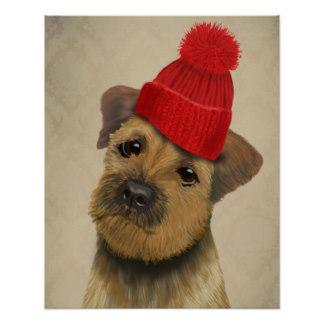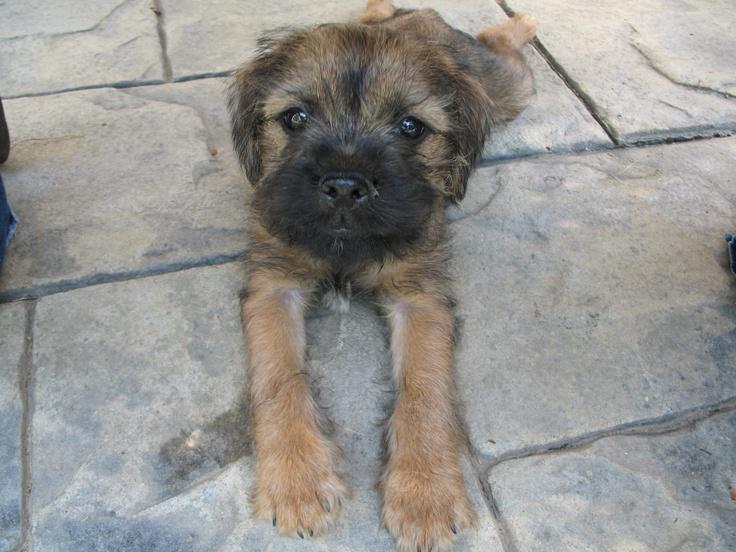The first image is the image on the left, the second image is the image on the right. For the images displayed, is the sentence "the dog has a hat with a brim in the right side pic" factually correct? Answer yes or no. No. The first image is the image on the left, the second image is the image on the right. Examine the images to the left and right. Is the description "The dog in the image on the right is wearing a hat with a black band around the crown." accurate? Answer yes or no. No. 